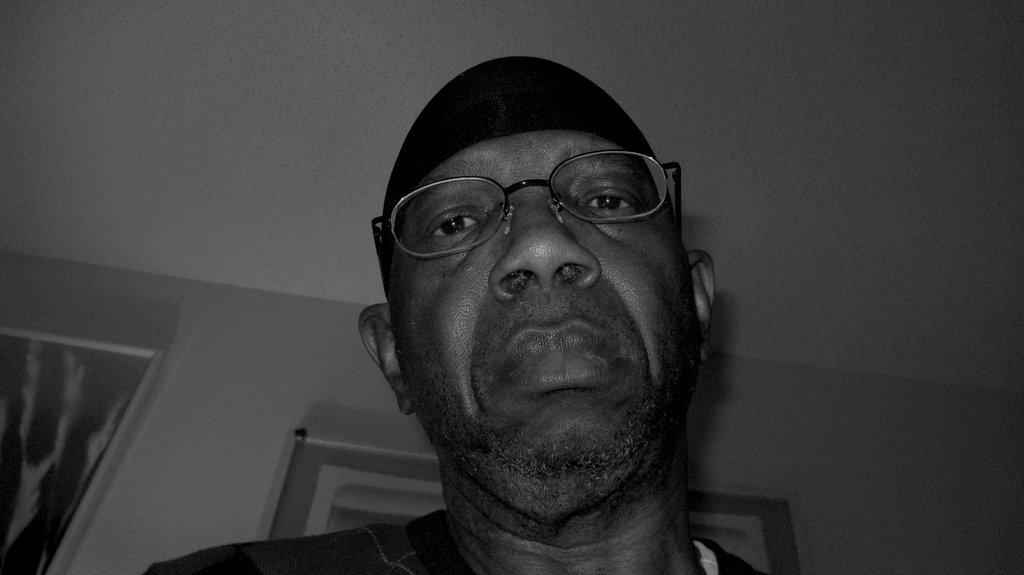What can be seen in the image? There is a person in the image. Can you describe the person's appearance? The person is wearing spectacles and a cap. What else is visible in the image? There are frames visible on the wall. What type of toothpaste is the person using in the image? There is no toothpaste present in the image. 